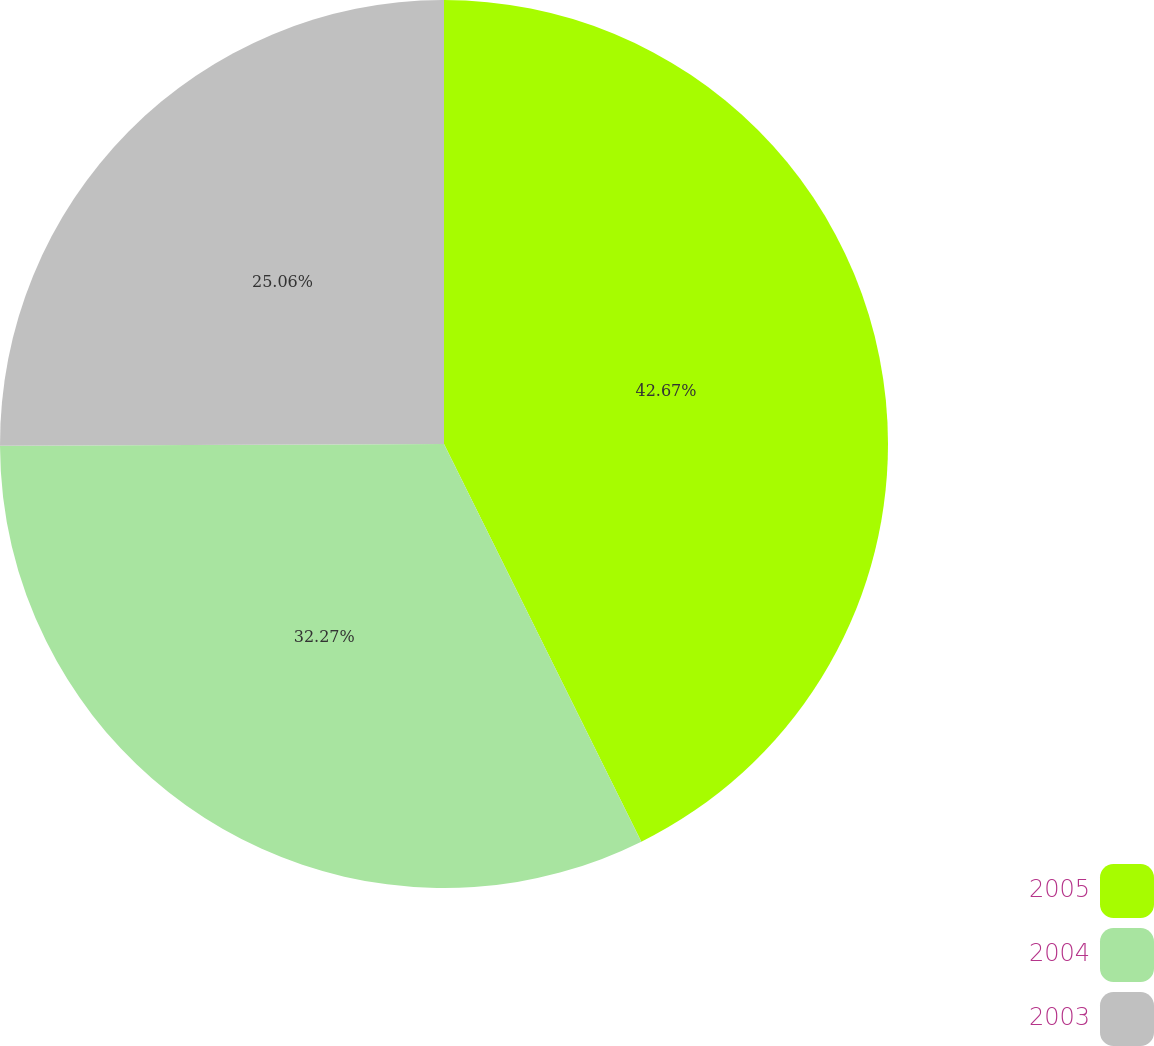Convert chart. <chart><loc_0><loc_0><loc_500><loc_500><pie_chart><fcel>2005<fcel>2004<fcel>2003<nl><fcel>42.67%<fcel>32.27%<fcel>25.06%<nl></chart> 